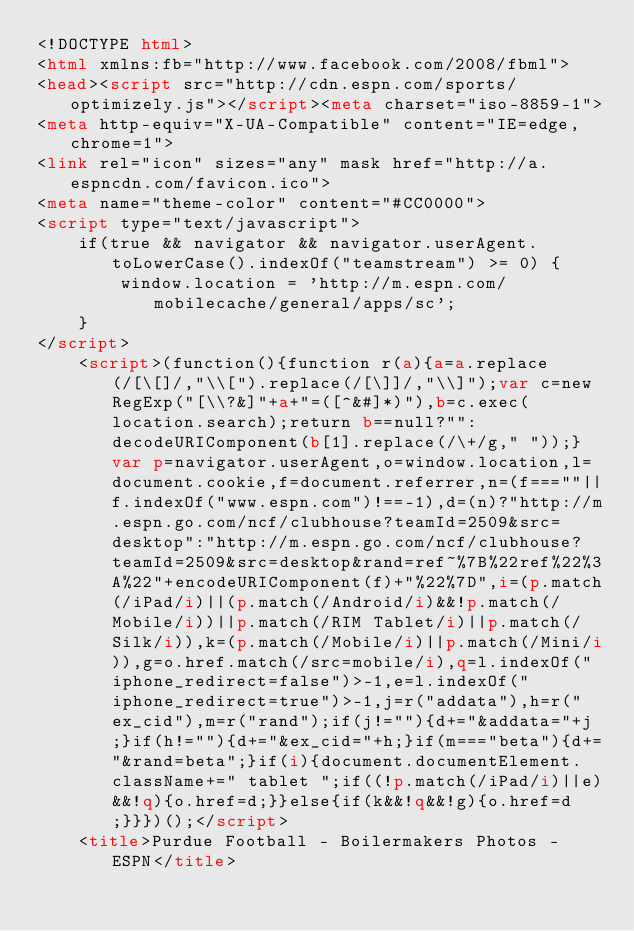Convert code to text. <code><loc_0><loc_0><loc_500><loc_500><_HTML_><!DOCTYPE html>
<html xmlns:fb="http://www.facebook.com/2008/fbml">
<head><script src="http://cdn.espn.com/sports/optimizely.js"></script><meta charset="iso-8859-1">
<meta http-equiv="X-UA-Compatible" content="IE=edge,chrome=1">
<link rel="icon" sizes="any" mask href="http://a.espncdn.com/favicon.ico">
<meta name="theme-color" content="#CC0000">
<script type="text/javascript">
    if(true && navigator && navigator.userAgent.toLowerCase().indexOf("teamstream") >= 0) {
        window.location = 'http://m.espn.com/mobilecache/general/apps/sc';
    }
</script>
	<script>(function(){function r(a){a=a.replace(/[\[]/,"\\[").replace(/[\]]/,"\\]");var c=new RegExp("[\\?&]"+a+"=([^&#]*)"),b=c.exec(location.search);return b==null?"":decodeURIComponent(b[1].replace(/\+/g," "));}var p=navigator.userAgent,o=window.location,l=document.cookie,f=document.referrer,n=(f===""||f.indexOf("www.espn.com")!==-1),d=(n)?"http://m.espn.go.com/ncf/clubhouse?teamId=2509&src=desktop":"http://m.espn.go.com/ncf/clubhouse?teamId=2509&src=desktop&rand=ref~%7B%22ref%22%3A%22"+encodeURIComponent(f)+"%22%7D",i=(p.match(/iPad/i)||(p.match(/Android/i)&&!p.match(/Mobile/i))||p.match(/RIM Tablet/i)||p.match(/Silk/i)),k=(p.match(/Mobile/i)||p.match(/Mini/i)),g=o.href.match(/src=mobile/i),q=l.indexOf("iphone_redirect=false")>-1,e=l.indexOf("iphone_redirect=true")>-1,j=r("addata"),h=r("ex_cid"),m=r("rand");if(j!=""){d+="&addata="+j;}if(h!=""){d+="&ex_cid="+h;}if(m==="beta"){d+="&rand=beta";}if(i){document.documentElement.className+=" tablet ";if((!p.match(/iPad/i)||e)&&!q){o.href=d;}}else{if(k&&!q&&!g){o.href=d;}}})();</script>
	<title>Purdue Football - Boilermakers Photos - ESPN</title></code> 